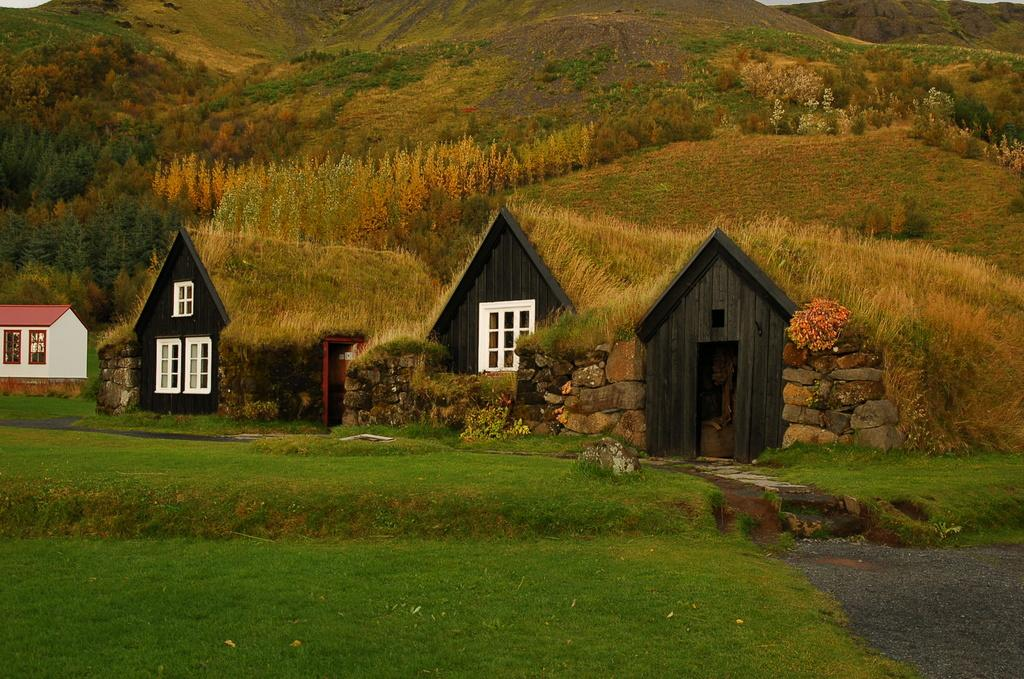What type of terrain is on the left side of the image? There is grass on the ground on the left side of the image. What type of terrain is on the right side of the image? There is dry land on the right side of the image. What structures can be seen in the background of the image? There are shelters with windows in the background of the image. What natural feature is visible in the background of the image? There are mountains visible in the background of the image. How many jellyfish can be seen swimming in the image? There are no jellyfish present in the image; it features grass, dry land, shelters, and mountains. What type of notebook is being used by the person in the image? There is no person or notebook present in the image. 